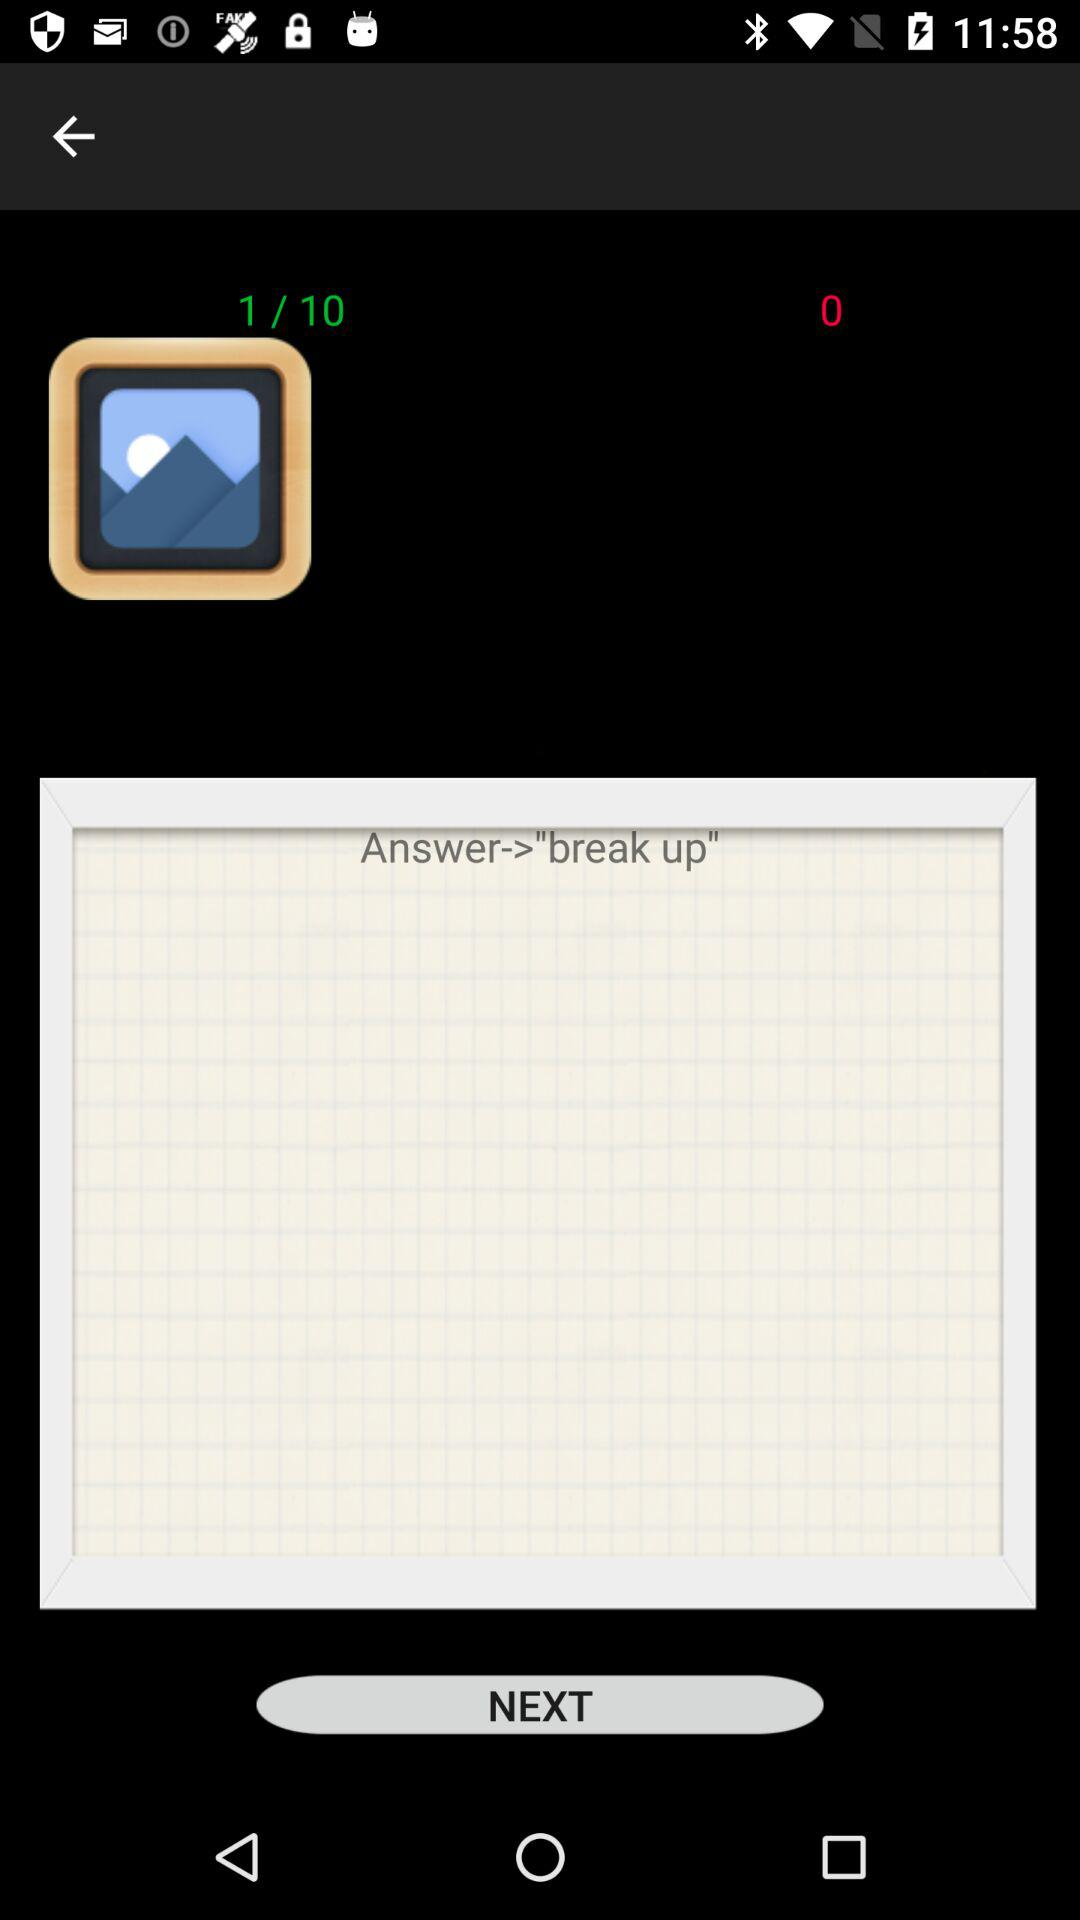What is the answer to the question?
Answer the question using a single word or phrase. Break up 